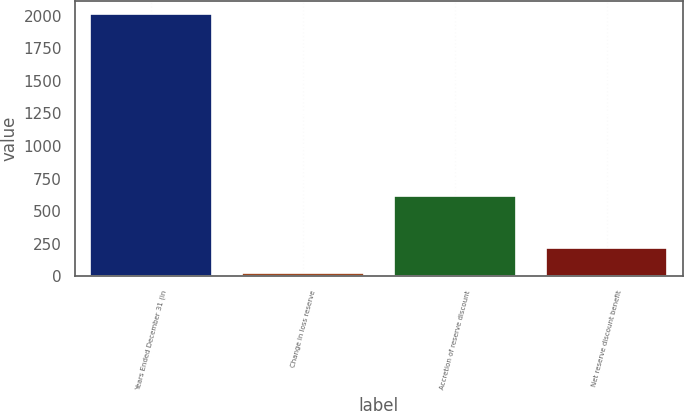<chart> <loc_0><loc_0><loc_500><loc_500><bar_chart><fcel>Years Ended December 31 (in<fcel>Change in loss reserve<fcel>Accretion of reserve discount<fcel>Net reserve discount benefit<nl><fcel>2011<fcel>22<fcel>618.7<fcel>220.9<nl></chart> 